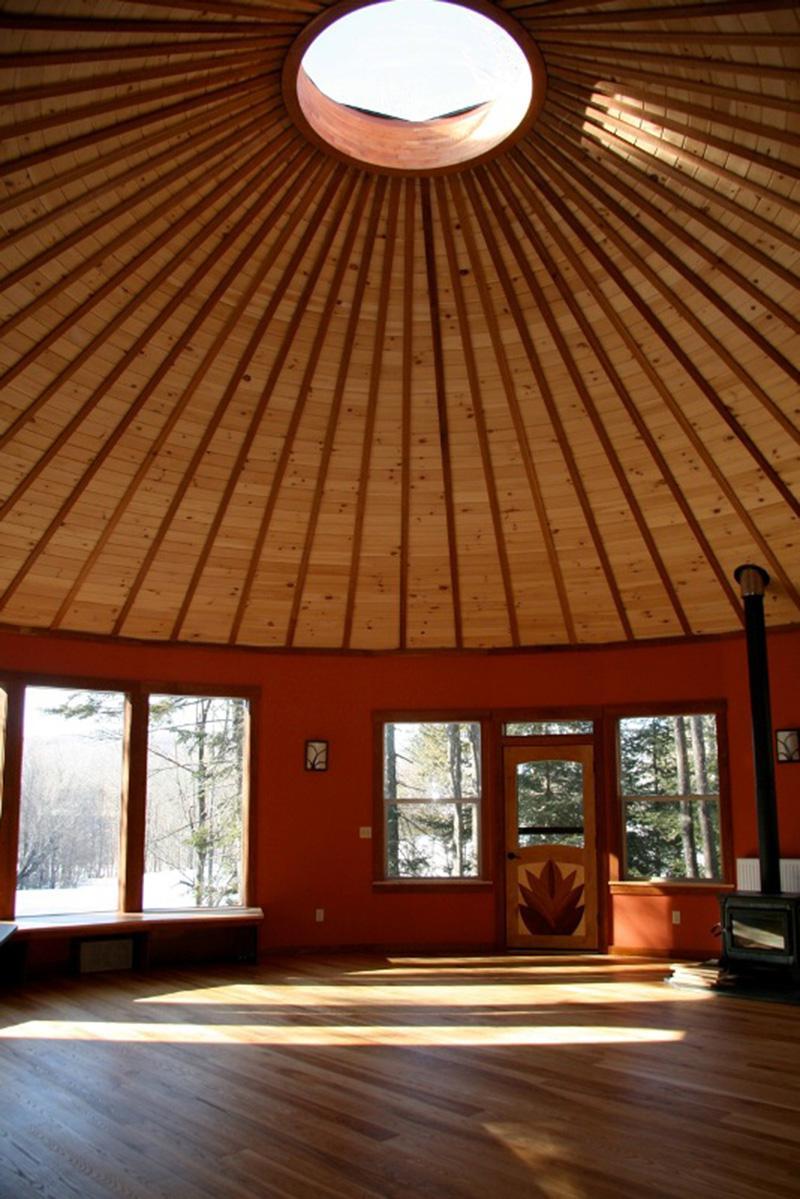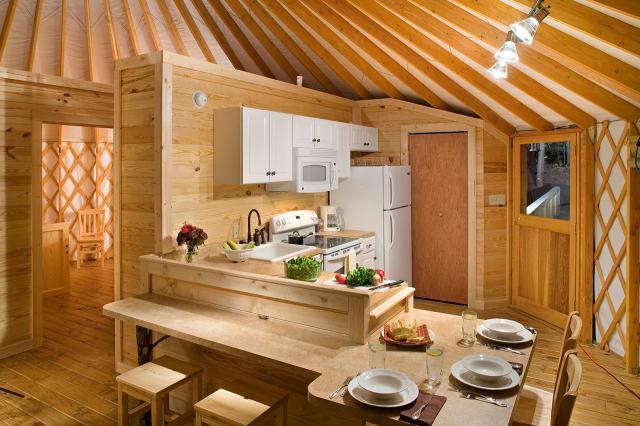The first image is the image on the left, the second image is the image on the right. Examine the images to the left and right. Is the description "A ceiling fan is hanging above a kitchen in the left image." accurate? Answer yes or no. No. The first image is the image on the left, the second image is the image on the right. Analyze the images presented: Is the assertion "One image shows the kitchen of a yurt with white refrigerator and microwave and a vase of flowers near a dining seating area with wooden kitchen chairs." valid? Answer yes or no. Yes. 